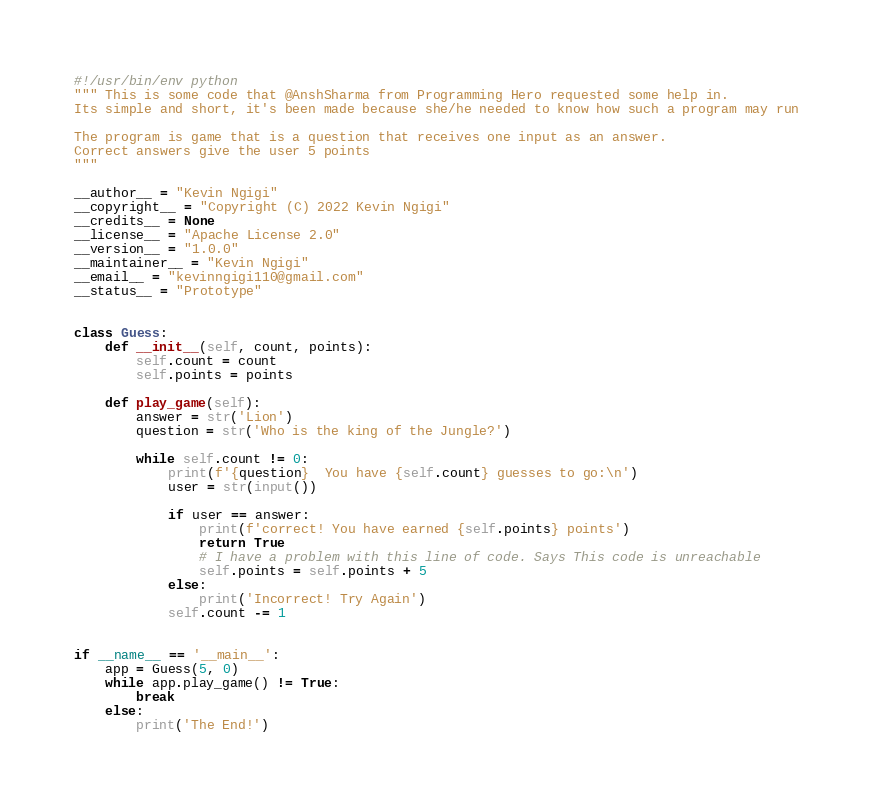Convert code to text. <code><loc_0><loc_0><loc_500><loc_500><_Python_>#!/usr/bin/env python
""" This is some code that @AnshSharma from Programming Hero requested some help in.
Its simple and short, it's been made because she/he needed to know how such a program may run

The program is game that is a question that receives one input as an answer.
Correct answers give the user 5 points
"""

__author__ = "Kevin Ngigi"
__copyright__ = "Copyright (C) 2022 Kevin Ngigi"
__credits__ = None
__license__ = "Apache License 2.0"
__version__ = "1.0.0"
__maintainer__ = "Kevin Ngigi"
__email__ = "kevinngigi110@gmail.com"
__status__ = "Prototype"


class Guess:
    def __init__(self, count, points):
        self.count = count
        self.points = points

    def play_game(self):
        answer = str('Lion')
        question = str('Who is the king of the Jungle?')

        while self.count != 0:
            print(f'{question}  You have {self.count} guesses to go:\n')
            user = str(input())

            if user == answer:
                print(f'correct! You have earned {self.points} points')
                return True
                # I have a problem with this line of code. Says This code is unreachable
                self.points = self.points + 5
            else:
                print('Incorrect! Try Again')
            self.count -= 1


if __name__ == '__main__':
    app = Guess(5, 0)
    while app.play_game() != True:
        break
    else:
        print('The End!')
</code> 